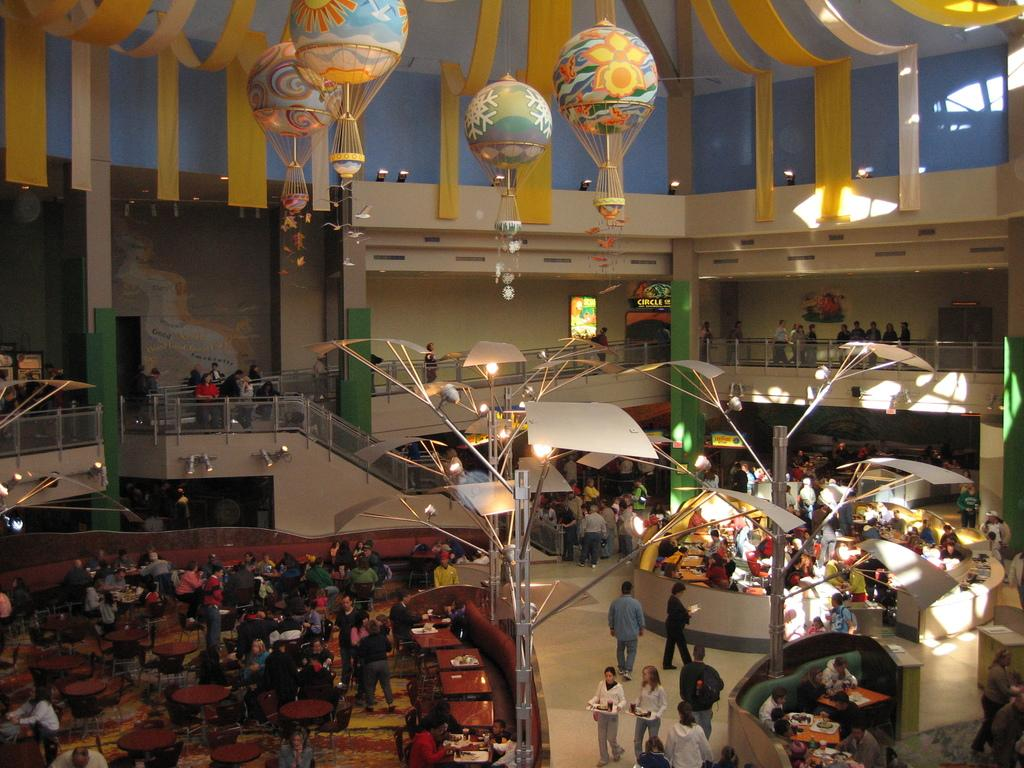What is located in the middle of the image? There are lights in the middle of the image. What type of furniture can be seen on the left side of the image? There are dining tables and chairs on the left side of the image. What are the people in the image doing? People are sitting on the chairs. What type of quince is being taught by the jellyfish in the image? There is no quince or jellyfish present in the image. 